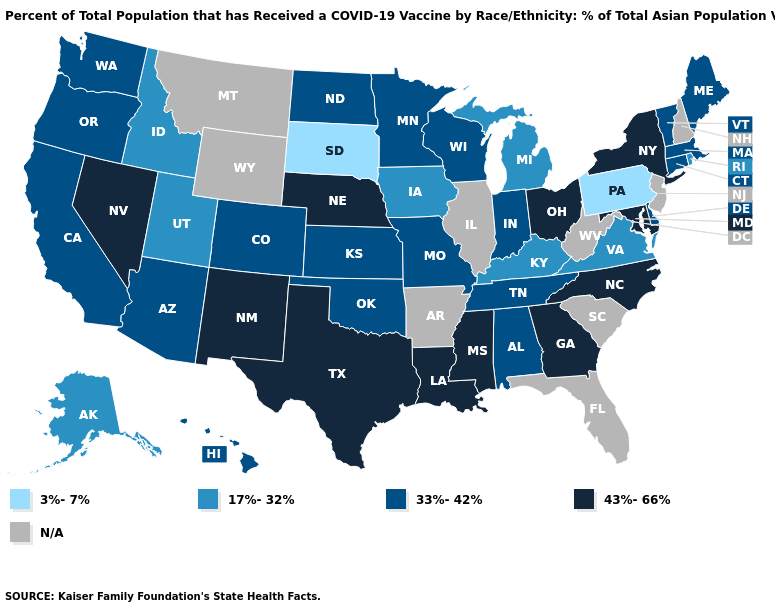What is the value of Nebraska?
Answer briefly. 43%-66%. Name the states that have a value in the range 43%-66%?
Quick response, please. Georgia, Louisiana, Maryland, Mississippi, Nebraska, Nevada, New Mexico, New York, North Carolina, Ohio, Texas. Name the states that have a value in the range 43%-66%?
Concise answer only. Georgia, Louisiana, Maryland, Mississippi, Nebraska, Nevada, New Mexico, New York, North Carolina, Ohio, Texas. Does the map have missing data?
Be succinct. Yes. Which states have the lowest value in the West?
Short answer required. Alaska, Idaho, Utah. How many symbols are there in the legend?
Write a very short answer. 5. Name the states that have a value in the range 33%-42%?
Write a very short answer. Alabama, Arizona, California, Colorado, Connecticut, Delaware, Hawaii, Indiana, Kansas, Maine, Massachusetts, Minnesota, Missouri, North Dakota, Oklahoma, Oregon, Tennessee, Vermont, Washington, Wisconsin. Among the states that border South Dakota , does Nebraska have the lowest value?
Give a very brief answer. No. Does the first symbol in the legend represent the smallest category?
Give a very brief answer. Yes. What is the value of West Virginia?
Quick response, please. N/A. What is the value of Alaska?
Write a very short answer. 17%-32%. What is the value of Texas?
Answer briefly. 43%-66%. Does Connecticut have the lowest value in the USA?
Quick response, please. No. What is the value of Nevada?
Quick response, please. 43%-66%. 